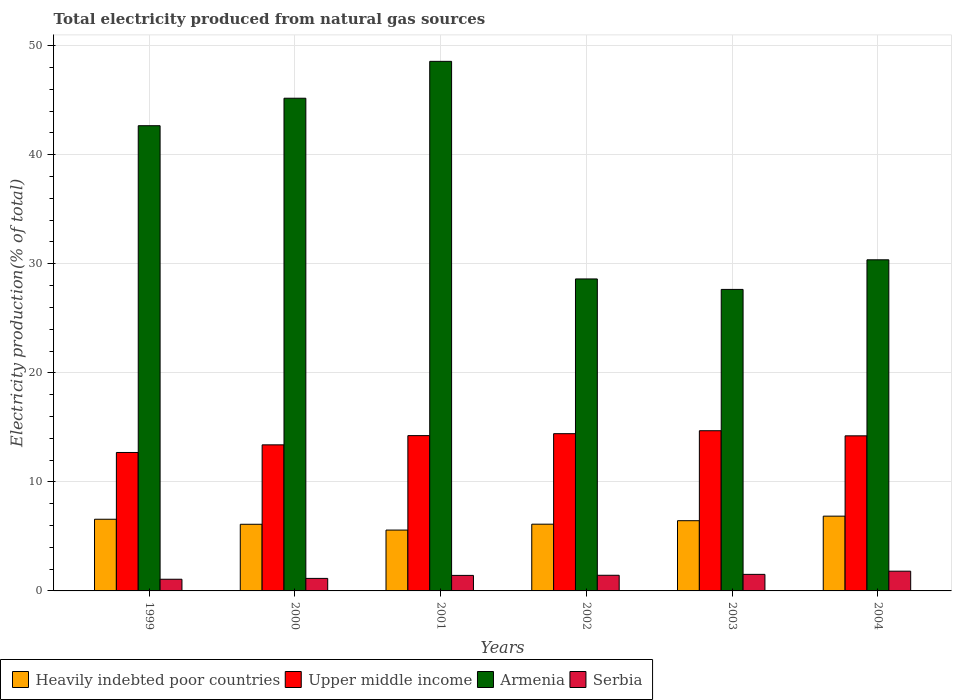How many groups of bars are there?
Offer a very short reply. 6. How many bars are there on the 3rd tick from the right?
Make the answer very short. 4. What is the total electricity produced in Armenia in 2004?
Provide a short and direct response. 30.36. Across all years, what is the maximum total electricity produced in Serbia?
Your answer should be compact. 1.81. Across all years, what is the minimum total electricity produced in Upper middle income?
Make the answer very short. 12.7. What is the total total electricity produced in Armenia in the graph?
Your response must be concise. 223.03. What is the difference between the total electricity produced in Serbia in 1999 and that in 2004?
Your answer should be compact. -0.74. What is the difference between the total electricity produced in Heavily indebted poor countries in 2000 and the total electricity produced in Serbia in 2004?
Give a very brief answer. 4.3. What is the average total electricity produced in Upper middle income per year?
Make the answer very short. 13.94. In the year 2004, what is the difference between the total electricity produced in Upper middle income and total electricity produced in Armenia?
Your response must be concise. -16.14. What is the ratio of the total electricity produced in Serbia in 1999 to that in 2001?
Your answer should be very brief. 0.75. Is the total electricity produced in Serbia in 2000 less than that in 2001?
Ensure brevity in your answer.  Yes. Is the difference between the total electricity produced in Upper middle income in 2000 and 2004 greater than the difference between the total electricity produced in Armenia in 2000 and 2004?
Your answer should be compact. No. What is the difference between the highest and the second highest total electricity produced in Heavily indebted poor countries?
Provide a succinct answer. 0.28. What is the difference between the highest and the lowest total electricity produced in Armenia?
Provide a succinct answer. 20.91. In how many years, is the total electricity produced in Armenia greater than the average total electricity produced in Armenia taken over all years?
Your answer should be compact. 3. Is the sum of the total electricity produced in Upper middle income in 2000 and 2004 greater than the maximum total electricity produced in Heavily indebted poor countries across all years?
Ensure brevity in your answer.  Yes. Is it the case that in every year, the sum of the total electricity produced in Serbia and total electricity produced in Upper middle income is greater than the sum of total electricity produced in Armenia and total electricity produced in Heavily indebted poor countries?
Make the answer very short. No. What does the 3rd bar from the left in 2003 represents?
Your answer should be very brief. Armenia. What does the 1st bar from the right in 2000 represents?
Keep it short and to the point. Serbia. Are all the bars in the graph horizontal?
Your answer should be compact. No. What is the difference between two consecutive major ticks on the Y-axis?
Give a very brief answer. 10. Are the values on the major ticks of Y-axis written in scientific E-notation?
Your answer should be very brief. No. Does the graph contain grids?
Give a very brief answer. Yes. Where does the legend appear in the graph?
Keep it short and to the point. Bottom left. What is the title of the graph?
Offer a terse response. Total electricity produced from natural gas sources. Does "Zimbabwe" appear as one of the legend labels in the graph?
Your response must be concise. No. What is the label or title of the X-axis?
Provide a succinct answer. Years. What is the Electricity production(% of total) of Heavily indebted poor countries in 1999?
Your answer should be very brief. 6.57. What is the Electricity production(% of total) in Upper middle income in 1999?
Offer a terse response. 12.7. What is the Electricity production(% of total) of Armenia in 1999?
Give a very brief answer. 42.66. What is the Electricity production(% of total) of Serbia in 1999?
Give a very brief answer. 1.07. What is the Electricity production(% of total) in Heavily indebted poor countries in 2000?
Keep it short and to the point. 6.11. What is the Electricity production(% of total) in Upper middle income in 2000?
Provide a short and direct response. 13.4. What is the Electricity production(% of total) in Armenia in 2000?
Your answer should be compact. 45.18. What is the Electricity production(% of total) in Serbia in 2000?
Your answer should be very brief. 1.15. What is the Electricity production(% of total) in Heavily indebted poor countries in 2001?
Give a very brief answer. 5.58. What is the Electricity production(% of total) of Upper middle income in 2001?
Ensure brevity in your answer.  14.24. What is the Electricity production(% of total) of Armenia in 2001?
Give a very brief answer. 48.56. What is the Electricity production(% of total) in Serbia in 2001?
Offer a very short reply. 1.42. What is the Electricity production(% of total) of Heavily indebted poor countries in 2002?
Make the answer very short. 6.12. What is the Electricity production(% of total) of Upper middle income in 2002?
Offer a very short reply. 14.42. What is the Electricity production(% of total) in Armenia in 2002?
Provide a short and direct response. 28.61. What is the Electricity production(% of total) in Serbia in 2002?
Provide a short and direct response. 1.43. What is the Electricity production(% of total) in Heavily indebted poor countries in 2003?
Keep it short and to the point. 6.44. What is the Electricity production(% of total) in Upper middle income in 2003?
Keep it short and to the point. 14.69. What is the Electricity production(% of total) of Armenia in 2003?
Your response must be concise. 27.65. What is the Electricity production(% of total) of Serbia in 2003?
Your answer should be compact. 1.52. What is the Electricity production(% of total) of Heavily indebted poor countries in 2004?
Offer a terse response. 6.86. What is the Electricity production(% of total) in Upper middle income in 2004?
Your response must be concise. 14.22. What is the Electricity production(% of total) of Armenia in 2004?
Provide a short and direct response. 30.36. What is the Electricity production(% of total) of Serbia in 2004?
Offer a terse response. 1.81. Across all years, what is the maximum Electricity production(% of total) of Heavily indebted poor countries?
Make the answer very short. 6.86. Across all years, what is the maximum Electricity production(% of total) of Upper middle income?
Offer a terse response. 14.69. Across all years, what is the maximum Electricity production(% of total) of Armenia?
Keep it short and to the point. 48.56. Across all years, what is the maximum Electricity production(% of total) of Serbia?
Keep it short and to the point. 1.81. Across all years, what is the minimum Electricity production(% of total) in Heavily indebted poor countries?
Your response must be concise. 5.58. Across all years, what is the minimum Electricity production(% of total) in Upper middle income?
Give a very brief answer. 12.7. Across all years, what is the minimum Electricity production(% of total) in Armenia?
Offer a very short reply. 27.65. Across all years, what is the minimum Electricity production(% of total) of Serbia?
Offer a terse response. 1.07. What is the total Electricity production(% of total) of Heavily indebted poor countries in the graph?
Make the answer very short. 37.68. What is the total Electricity production(% of total) of Upper middle income in the graph?
Ensure brevity in your answer.  83.67. What is the total Electricity production(% of total) in Armenia in the graph?
Your answer should be very brief. 223.03. What is the total Electricity production(% of total) of Serbia in the graph?
Provide a short and direct response. 8.41. What is the difference between the Electricity production(% of total) of Heavily indebted poor countries in 1999 and that in 2000?
Make the answer very short. 0.46. What is the difference between the Electricity production(% of total) in Upper middle income in 1999 and that in 2000?
Your response must be concise. -0.7. What is the difference between the Electricity production(% of total) in Armenia in 1999 and that in 2000?
Your answer should be compact. -2.52. What is the difference between the Electricity production(% of total) in Serbia in 1999 and that in 2000?
Provide a short and direct response. -0.08. What is the difference between the Electricity production(% of total) of Upper middle income in 1999 and that in 2001?
Your answer should be compact. -1.55. What is the difference between the Electricity production(% of total) of Armenia in 1999 and that in 2001?
Your answer should be very brief. -5.9. What is the difference between the Electricity production(% of total) in Serbia in 1999 and that in 2001?
Your answer should be compact. -0.35. What is the difference between the Electricity production(% of total) in Heavily indebted poor countries in 1999 and that in 2002?
Your answer should be very brief. 0.45. What is the difference between the Electricity production(% of total) in Upper middle income in 1999 and that in 2002?
Your answer should be compact. -1.72. What is the difference between the Electricity production(% of total) of Armenia in 1999 and that in 2002?
Your response must be concise. 14.05. What is the difference between the Electricity production(% of total) of Serbia in 1999 and that in 2002?
Your answer should be compact. -0.36. What is the difference between the Electricity production(% of total) in Heavily indebted poor countries in 1999 and that in 2003?
Keep it short and to the point. 0.13. What is the difference between the Electricity production(% of total) of Upper middle income in 1999 and that in 2003?
Give a very brief answer. -1.99. What is the difference between the Electricity production(% of total) in Armenia in 1999 and that in 2003?
Offer a terse response. 15.01. What is the difference between the Electricity production(% of total) of Serbia in 1999 and that in 2003?
Your answer should be very brief. -0.45. What is the difference between the Electricity production(% of total) of Heavily indebted poor countries in 1999 and that in 2004?
Offer a terse response. -0.28. What is the difference between the Electricity production(% of total) of Upper middle income in 1999 and that in 2004?
Ensure brevity in your answer.  -1.53. What is the difference between the Electricity production(% of total) in Armenia in 1999 and that in 2004?
Provide a succinct answer. 12.3. What is the difference between the Electricity production(% of total) of Serbia in 1999 and that in 2004?
Offer a terse response. -0.74. What is the difference between the Electricity production(% of total) in Heavily indebted poor countries in 2000 and that in 2001?
Make the answer very short. 0.53. What is the difference between the Electricity production(% of total) of Upper middle income in 2000 and that in 2001?
Your answer should be compact. -0.85. What is the difference between the Electricity production(% of total) of Armenia in 2000 and that in 2001?
Ensure brevity in your answer.  -3.38. What is the difference between the Electricity production(% of total) of Serbia in 2000 and that in 2001?
Keep it short and to the point. -0.28. What is the difference between the Electricity production(% of total) of Heavily indebted poor countries in 2000 and that in 2002?
Ensure brevity in your answer.  -0.01. What is the difference between the Electricity production(% of total) in Upper middle income in 2000 and that in 2002?
Your answer should be very brief. -1.02. What is the difference between the Electricity production(% of total) of Armenia in 2000 and that in 2002?
Offer a very short reply. 16.57. What is the difference between the Electricity production(% of total) in Serbia in 2000 and that in 2002?
Your response must be concise. -0.29. What is the difference between the Electricity production(% of total) in Heavily indebted poor countries in 2000 and that in 2003?
Your answer should be very brief. -0.33. What is the difference between the Electricity production(% of total) of Upper middle income in 2000 and that in 2003?
Your response must be concise. -1.3. What is the difference between the Electricity production(% of total) of Armenia in 2000 and that in 2003?
Provide a succinct answer. 17.53. What is the difference between the Electricity production(% of total) in Serbia in 2000 and that in 2003?
Offer a very short reply. -0.37. What is the difference between the Electricity production(% of total) in Heavily indebted poor countries in 2000 and that in 2004?
Your answer should be compact. -0.74. What is the difference between the Electricity production(% of total) of Upper middle income in 2000 and that in 2004?
Ensure brevity in your answer.  -0.83. What is the difference between the Electricity production(% of total) in Armenia in 2000 and that in 2004?
Provide a short and direct response. 14.82. What is the difference between the Electricity production(% of total) of Serbia in 2000 and that in 2004?
Provide a succinct answer. -0.66. What is the difference between the Electricity production(% of total) in Heavily indebted poor countries in 2001 and that in 2002?
Provide a short and direct response. -0.54. What is the difference between the Electricity production(% of total) of Upper middle income in 2001 and that in 2002?
Ensure brevity in your answer.  -0.18. What is the difference between the Electricity production(% of total) in Armenia in 2001 and that in 2002?
Your answer should be compact. 19.95. What is the difference between the Electricity production(% of total) of Serbia in 2001 and that in 2002?
Your answer should be very brief. -0.01. What is the difference between the Electricity production(% of total) of Heavily indebted poor countries in 2001 and that in 2003?
Ensure brevity in your answer.  -0.86. What is the difference between the Electricity production(% of total) of Upper middle income in 2001 and that in 2003?
Offer a terse response. -0.45. What is the difference between the Electricity production(% of total) in Armenia in 2001 and that in 2003?
Offer a terse response. 20.91. What is the difference between the Electricity production(% of total) in Serbia in 2001 and that in 2003?
Offer a terse response. -0.1. What is the difference between the Electricity production(% of total) in Heavily indebted poor countries in 2001 and that in 2004?
Ensure brevity in your answer.  -1.28. What is the difference between the Electricity production(% of total) of Upper middle income in 2001 and that in 2004?
Offer a terse response. 0.02. What is the difference between the Electricity production(% of total) of Armenia in 2001 and that in 2004?
Ensure brevity in your answer.  18.2. What is the difference between the Electricity production(% of total) of Serbia in 2001 and that in 2004?
Your answer should be very brief. -0.39. What is the difference between the Electricity production(% of total) in Heavily indebted poor countries in 2002 and that in 2003?
Your answer should be very brief. -0.32. What is the difference between the Electricity production(% of total) of Upper middle income in 2002 and that in 2003?
Offer a terse response. -0.27. What is the difference between the Electricity production(% of total) in Armenia in 2002 and that in 2003?
Give a very brief answer. 0.96. What is the difference between the Electricity production(% of total) in Serbia in 2002 and that in 2003?
Ensure brevity in your answer.  -0.08. What is the difference between the Electricity production(% of total) of Heavily indebted poor countries in 2002 and that in 2004?
Make the answer very short. -0.74. What is the difference between the Electricity production(% of total) of Upper middle income in 2002 and that in 2004?
Provide a succinct answer. 0.2. What is the difference between the Electricity production(% of total) of Armenia in 2002 and that in 2004?
Give a very brief answer. -1.75. What is the difference between the Electricity production(% of total) of Serbia in 2002 and that in 2004?
Offer a terse response. -0.38. What is the difference between the Electricity production(% of total) in Heavily indebted poor countries in 2003 and that in 2004?
Your response must be concise. -0.42. What is the difference between the Electricity production(% of total) in Upper middle income in 2003 and that in 2004?
Make the answer very short. 0.47. What is the difference between the Electricity production(% of total) of Armenia in 2003 and that in 2004?
Keep it short and to the point. -2.72. What is the difference between the Electricity production(% of total) of Serbia in 2003 and that in 2004?
Give a very brief answer. -0.29. What is the difference between the Electricity production(% of total) in Heavily indebted poor countries in 1999 and the Electricity production(% of total) in Upper middle income in 2000?
Offer a very short reply. -6.82. What is the difference between the Electricity production(% of total) of Heavily indebted poor countries in 1999 and the Electricity production(% of total) of Armenia in 2000?
Provide a short and direct response. -38.61. What is the difference between the Electricity production(% of total) of Heavily indebted poor countries in 1999 and the Electricity production(% of total) of Serbia in 2000?
Provide a short and direct response. 5.42. What is the difference between the Electricity production(% of total) of Upper middle income in 1999 and the Electricity production(% of total) of Armenia in 2000?
Offer a terse response. -32.49. What is the difference between the Electricity production(% of total) in Upper middle income in 1999 and the Electricity production(% of total) in Serbia in 2000?
Provide a succinct answer. 11.55. What is the difference between the Electricity production(% of total) of Armenia in 1999 and the Electricity production(% of total) of Serbia in 2000?
Provide a succinct answer. 41.51. What is the difference between the Electricity production(% of total) in Heavily indebted poor countries in 1999 and the Electricity production(% of total) in Upper middle income in 2001?
Ensure brevity in your answer.  -7.67. What is the difference between the Electricity production(% of total) of Heavily indebted poor countries in 1999 and the Electricity production(% of total) of Armenia in 2001?
Keep it short and to the point. -41.99. What is the difference between the Electricity production(% of total) of Heavily indebted poor countries in 1999 and the Electricity production(% of total) of Serbia in 2001?
Provide a short and direct response. 5.15. What is the difference between the Electricity production(% of total) of Upper middle income in 1999 and the Electricity production(% of total) of Armenia in 2001?
Give a very brief answer. -35.87. What is the difference between the Electricity production(% of total) of Upper middle income in 1999 and the Electricity production(% of total) of Serbia in 2001?
Offer a terse response. 11.27. What is the difference between the Electricity production(% of total) in Armenia in 1999 and the Electricity production(% of total) in Serbia in 2001?
Provide a short and direct response. 41.24. What is the difference between the Electricity production(% of total) in Heavily indebted poor countries in 1999 and the Electricity production(% of total) in Upper middle income in 2002?
Your answer should be very brief. -7.85. What is the difference between the Electricity production(% of total) in Heavily indebted poor countries in 1999 and the Electricity production(% of total) in Armenia in 2002?
Make the answer very short. -22.04. What is the difference between the Electricity production(% of total) of Heavily indebted poor countries in 1999 and the Electricity production(% of total) of Serbia in 2002?
Offer a very short reply. 5.14. What is the difference between the Electricity production(% of total) in Upper middle income in 1999 and the Electricity production(% of total) in Armenia in 2002?
Offer a terse response. -15.91. What is the difference between the Electricity production(% of total) in Upper middle income in 1999 and the Electricity production(% of total) in Serbia in 2002?
Provide a short and direct response. 11.26. What is the difference between the Electricity production(% of total) of Armenia in 1999 and the Electricity production(% of total) of Serbia in 2002?
Your answer should be compact. 41.23. What is the difference between the Electricity production(% of total) in Heavily indebted poor countries in 1999 and the Electricity production(% of total) in Upper middle income in 2003?
Offer a very short reply. -8.12. What is the difference between the Electricity production(% of total) of Heavily indebted poor countries in 1999 and the Electricity production(% of total) of Armenia in 2003?
Offer a terse response. -21.08. What is the difference between the Electricity production(% of total) in Heavily indebted poor countries in 1999 and the Electricity production(% of total) in Serbia in 2003?
Offer a terse response. 5.05. What is the difference between the Electricity production(% of total) in Upper middle income in 1999 and the Electricity production(% of total) in Armenia in 2003?
Make the answer very short. -14.95. What is the difference between the Electricity production(% of total) in Upper middle income in 1999 and the Electricity production(% of total) in Serbia in 2003?
Your answer should be very brief. 11.18. What is the difference between the Electricity production(% of total) in Armenia in 1999 and the Electricity production(% of total) in Serbia in 2003?
Provide a succinct answer. 41.14. What is the difference between the Electricity production(% of total) in Heavily indebted poor countries in 1999 and the Electricity production(% of total) in Upper middle income in 2004?
Offer a terse response. -7.65. What is the difference between the Electricity production(% of total) of Heavily indebted poor countries in 1999 and the Electricity production(% of total) of Armenia in 2004?
Provide a succinct answer. -23.79. What is the difference between the Electricity production(% of total) of Heavily indebted poor countries in 1999 and the Electricity production(% of total) of Serbia in 2004?
Provide a succinct answer. 4.76. What is the difference between the Electricity production(% of total) of Upper middle income in 1999 and the Electricity production(% of total) of Armenia in 2004?
Offer a very short reply. -17.67. What is the difference between the Electricity production(% of total) in Upper middle income in 1999 and the Electricity production(% of total) in Serbia in 2004?
Make the answer very short. 10.89. What is the difference between the Electricity production(% of total) in Armenia in 1999 and the Electricity production(% of total) in Serbia in 2004?
Provide a short and direct response. 40.85. What is the difference between the Electricity production(% of total) of Heavily indebted poor countries in 2000 and the Electricity production(% of total) of Upper middle income in 2001?
Your response must be concise. -8.13. What is the difference between the Electricity production(% of total) in Heavily indebted poor countries in 2000 and the Electricity production(% of total) in Armenia in 2001?
Provide a succinct answer. -42.45. What is the difference between the Electricity production(% of total) of Heavily indebted poor countries in 2000 and the Electricity production(% of total) of Serbia in 2001?
Provide a short and direct response. 4.69. What is the difference between the Electricity production(% of total) of Upper middle income in 2000 and the Electricity production(% of total) of Armenia in 2001?
Your answer should be very brief. -35.17. What is the difference between the Electricity production(% of total) in Upper middle income in 2000 and the Electricity production(% of total) in Serbia in 2001?
Make the answer very short. 11.97. What is the difference between the Electricity production(% of total) in Armenia in 2000 and the Electricity production(% of total) in Serbia in 2001?
Your response must be concise. 43.76. What is the difference between the Electricity production(% of total) in Heavily indebted poor countries in 2000 and the Electricity production(% of total) in Upper middle income in 2002?
Make the answer very short. -8.31. What is the difference between the Electricity production(% of total) of Heavily indebted poor countries in 2000 and the Electricity production(% of total) of Armenia in 2002?
Make the answer very short. -22.5. What is the difference between the Electricity production(% of total) of Heavily indebted poor countries in 2000 and the Electricity production(% of total) of Serbia in 2002?
Ensure brevity in your answer.  4.68. What is the difference between the Electricity production(% of total) in Upper middle income in 2000 and the Electricity production(% of total) in Armenia in 2002?
Offer a very short reply. -15.21. What is the difference between the Electricity production(% of total) in Upper middle income in 2000 and the Electricity production(% of total) in Serbia in 2002?
Keep it short and to the point. 11.96. What is the difference between the Electricity production(% of total) of Armenia in 2000 and the Electricity production(% of total) of Serbia in 2002?
Make the answer very short. 43.75. What is the difference between the Electricity production(% of total) in Heavily indebted poor countries in 2000 and the Electricity production(% of total) in Upper middle income in 2003?
Your answer should be compact. -8.58. What is the difference between the Electricity production(% of total) of Heavily indebted poor countries in 2000 and the Electricity production(% of total) of Armenia in 2003?
Keep it short and to the point. -21.54. What is the difference between the Electricity production(% of total) in Heavily indebted poor countries in 2000 and the Electricity production(% of total) in Serbia in 2003?
Your answer should be compact. 4.59. What is the difference between the Electricity production(% of total) of Upper middle income in 2000 and the Electricity production(% of total) of Armenia in 2003?
Provide a succinct answer. -14.25. What is the difference between the Electricity production(% of total) in Upper middle income in 2000 and the Electricity production(% of total) in Serbia in 2003?
Offer a terse response. 11.88. What is the difference between the Electricity production(% of total) of Armenia in 2000 and the Electricity production(% of total) of Serbia in 2003?
Your answer should be compact. 43.66. What is the difference between the Electricity production(% of total) in Heavily indebted poor countries in 2000 and the Electricity production(% of total) in Upper middle income in 2004?
Give a very brief answer. -8.11. What is the difference between the Electricity production(% of total) of Heavily indebted poor countries in 2000 and the Electricity production(% of total) of Armenia in 2004?
Your answer should be very brief. -24.25. What is the difference between the Electricity production(% of total) in Heavily indebted poor countries in 2000 and the Electricity production(% of total) in Serbia in 2004?
Offer a terse response. 4.3. What is the difference between the Electricity production(% of total) of Upper middle income in 2000 and the Electricity production(% of total) of Armenia in 2004?
Give a very brief answer. -16.97. What is the difference between the Electricity production(% of total) in Upper middle income in 2000 and the Electricity production(% of total) in Serbia in 2004?
Your response must be concise. 11.59. What is the difference between the Electricity production(% of total) in Armenia in 2000 and the Electricity production(% of total) in Serbia in 2004?
Your response must be concise. 43.37. What is the difference between the Electricity production(% of total) of Heavily indebted poor countries in 2001 and the Electricity production(% of total) of Upper middle income in 2002?
Your answer should be compact. -8.84. What is the difference between the Electricity production(% of total) of Heavily indebted poor countries in 2001 and the Electricity production(% of total) of Armenia in 2002?
Provide a short and direct response. -23.03. What is the difference between the Electricity production(% of total) of Heavily indebted poor countries in 2001 and the Electricity production(% of total) of Serbia in 2002?
Your response must be concise. 4.15. What is the difference between the Electricity production(% of total) in Upper middle income in 2001 and the Electricity production(% of total) in Armenia in 2002?
Make the answer very short. -14.37. What is the difference between the Electricity production(% of total) of Upper middle income in 2001 and the Electricity production(% of total) of Serbia in 2002?
Your answer should be compact. 12.81. What is the difference between the Electricity production(% of total) in Armenia in 2001 and the Electricity production(% of total) in Serbia in 2002?
Offer a terse response. 47.13. What is the difference between the Electricity production(% of total) of Heavily indebted poor countries in 2001 and the Electricity production(% of total) of Upper middle income in 2003?
Provide a short and direct response. -9.11. What is the difference between the Electricity production(% of total) in Heavily indebted poor countries in 2001 and the Electricity production(% of total) in Armenia in 2003?
Provide a succinct answer. -22.07. What is the difference between the Electricity production(% of total) of Heavily indebted poor countries in 2001 and the Electricity production(% of total) of Serbia in 2003?
Make the answer very short. 4.06. What is the difference between the Electricity production(% of total) in Upper middle income in 2001 and the Electricity production(% of total) in Armenia in 2003?
Provide a succinct answer. -13.41. What is the difference between the Electricity production(% of total) in Upper middle income in 2001 and the Electricity production(% of total) in Serbia in 2003?
Offer a terse response. 12.72. What is the difference between the Electricity production(% of total) in Armenia in 2001 and the Electricity production(% of total) in Serbia in 2003?
Give a very brief answer. 47.05. What is the difference between the Electricity production(% of total) of Heavily indebted poor countries in 2001 and the Electricity production(% of total) of Upper middle income in 2004?
Provide a succinct answer. -8.64. What is the difference between the Electricity production(% of total) of Heavily indebted poor countries in 2001 and the Electricity production(% of total) of Armenia in 2004?
Give a very brief answer. -24.78. What is the difference between the Electricity production(% of total) of Heavily indebted poor countries in 2001 and the Electricity production(% of total) of Serbia in 2004?
Provide a short and direct response. 3.77. What is the difference between the Electricity production(% of total) in Upper middle income in 2001 and the Electricity production(% of total) in Armenia in 2004?
Your answer should be compact. -16.12. What is the difference between the Electricity production(% of total) in Upper middle income in 2001 and the Electricity production(% of total) in Serbia in 2004?
Your answer should be compact. 12.43. What is the difference between the Electricity production(% of total) of Armenia in 2001 and the Electricity production(% of total) of Serbia in 2004?
Ensure brevity in your answer.  46.75. What is the difference between the Electricity production(% of total) in Heavily indebted poor countries in 2002 and the Electricity production(% of total) in Upper middle income in 2003?
Your answer should be very brief. -8.57. What is the difference between the Electricity production(% of total) of Heavily indebted poor countries in 2002 and the Electricity production(% of total) of Armenia in 2003?
Ensure brevity in your answer.  -21.53. What is the difference between the Electricity production(% of total) in Heavily indebted poor countries in 2002 and the Electricity production(% of total) in Serbia in 2003?
Give a very brief answer. 4.6. What is the difference between the Electricity production(% of total) of Upper middle income in 2002 and the Electricity production(% of total) of Armenia in 2003?
Offer a terse response. -13.23. What is the difference between the Electricity production(% of total) in Upper middle income in 2002 and the Electricity production(% of total) in Serbia in 2003?
Your response must be concise. 12.9. What is the difference between the Electricity production(% of total) of Armenia in 2002 and the Electricity production(% of total) of Serbia in 2003?
Make the answer very short. 27.09. What is the difference between the Electricity production(% of total) of Heavily indebted poor countries in 2002 and the Electricity production(% of total) of Upper middle income in 2004?
Your answer should be very brief. -8.1. What is the difference between the Electricity production(% of total) of Heavily indebted poor countries in 2002 and the Electricity production(% of total) of Armenia in 2004?
Offer a very short reply. -24.24. What is the difference between the Electricity production(% of total) in Heavily indebted poor countries in 2002 and the Electricity production(% of total) in Serbia in 2004?
Your answer should be compact. 4.31. What is the difference between the Electricity production(% of total) of Upper middle income in 2002 and the Electricity production(% of total) of Armenia in 2004?
Provide a short and direct response. -15.94. What is the difference between the Electricity production(% of total) in Upper middle income in 2002 and the Electricity production(% of total) in Serbia in 2004?
Your answer should be very brief. 12.61. What is the difference between the Electricity production(% of total) in Armenia in 2002 and the Electricity production(% of total) in Serbia in 2004?
Your answer should be compact. 26.8. What is the difference between the Electricity production(% of total) in Heavily indebted poor countries in 2003 and the Electricity production(% of total) in Upper middle income in 2004?
Ensure brevity in your answer.  -7.78. What is the difference between the Electricity production(% of total) in Heavily indebted poor countries in 2003 and the Electricity production(% of total) in Armenia in 2004?
Make the answer very short. -23.93. What is the difference between the Electricity production(% of total) in Heavily indebted poor countries in 2003 and the Electricity production(% of total) in Serbia in 2004?
Provide a short and direct response. 4.63. What is the difference between the Electricity production(% of total) in Upper middle income in 2003 and the Electricity production(% of total) in Armenia in 2004?
Your answer should be very brief. -15.67. What is the difference between the Electricity production(% of total) of Upper middle income in 2003 and the Electricity production(% of total) of Serbia in 2004?
Your answer should be compact. 12.88. What is the difference between the Electricity production(% of total) of Armenia in 2003 and the Electricity production(% of total) of Serbia in 2004?
Offer a very short reply. 25.84. What is the average Electricity production(% of total) in Heavily indebted poor countries per year?
Your answer should be compact. 6.28. What is the average Electricity production(% of total) of Upper middle income per year?
Your answer should be very brief. 13.94. What is the average Electricity production(% of total) of Armenia per year?
Your response must be concise. 37.17. What is the average Electricity production(% of total) in Serbia per year?
Your answer should be very brief. 1.4. In the year 1999, what is the difference between the Electricity production(% of total) of Heavily indebted poor countries and Electricity production(% of total) of Upper middle income?
Provide a short and direct response. -6.12. In the year 1999, what is the difference between the Electricity production(% of total) in Heavily indebted poor countries and Electricity production(% of total) in Armenia?
Your answer should be compact. -36.09. In the year 1999, what is the difference between the Electricity production(% of total) in Heavily indebted poor countries and Electricity production(% of total) in Serbia?
Offer a terse response. 5.5. In the year 1999, what is the difference between the Electricity production(% of total) in Upper middle income and Electricity production(% of total) in Armenia?
Offer a terse response. -29.97. In the year 1999, what is the difference between the Electricity production(% of total) of Upper middle income and Electricity production(% of total) of Serbia?
Provide a short and direct response. 11.62. In the year 1999, what is the difference between the Electricity production(% of total) of Armenia and Electricity production(% of total) of Serbia?
Offer a very short reply. 41.59. In the year 2000, what is the difference between the Electricity production(% of total) in Heavily indebted poor countries and Electricity production(% of total) in Upper middle income?
Give a very brief answer. -7.28. In the year 2000, what is the difference between the Electricity production(% of total) in Heavily indebted poor countries and Electricity production(% of total) in Armenia?
Your response must be concise. -39.07. In the year 2000, what is the difference between the Electricity production(% of total) in Heavily indebted poor countries and Electricity production(% of total) in Serbia?
Make the answer very short. 4.96. In the year 2000, what is the difference between the Electricity production(% of total) in Upper middle income and Electricity production(% of total) in Armenia?
Your answer should be very brief. -31.79. In the year 2000, what is the difference between the Electricity production(% of total) of Upper middle income and Electricity production(% of total) of Serbia?
Keep it short and to the point. 12.25. In the year 2000, what is the difference between the Electricity production(% of total) in Armenia and Electricity production(% of total) in Serbia?
Offer a very short reply. 44.03. In the year 2001, what is the difference between the Electricity production(% of total) in Heavily indebted poor countries and Electricity production(% of total) in Upper middle income?
Offer a terse response. -8.66. In the year 2001, what is the difference between the Electricity production(% of total) of Heavily indebted poor countries and Electricity production(% of total) of Armenia?
Offer a terse response. -42.98. In the year 2001, what is the difference between the Electricity production(% of total) in Heavily indebted poor countries and Electricity production(% of total) in Serbia?
Make the answer very short. 4.16. In the year 2001, what is the difference between the Electricity production(% of total) in Upper middle income and Electricity production(% of total) in Armenia?
Your answer should be compact. -34.32. In the year 2001, what is the difference between the Electricity production(% of total) of Upper middle income and Electricity production(% of total) of Serbia?
Make the answer very short. 12.82. In the year 2001, what is the difference between the Electricity production(% of total) of Armenia and Electricity production(% of total) of Serbia?
Give a very brief answer. 47.14. In the year 2002, what is the difference between the Electricity production(% of total) in Heavily indebted poor countries and Electricity production(% of total) in Upper middle income?
Keep it short and to the point. -8.3. In the year 2002, what is the difference between the Electricity production(% of total) in Heavily indebted poor countries and Electricity production(% of total) in Armenia?
Make the answer very short. -22.49. In the year 2002, what is the difference between the Electricity production(% of total) of Heavily indebted poor countries and Electricity production(% of total) of Serbia?
Your answer should be compact. 4.69. In the year 2002, what is the difference between the Electricity production(% of total) of Upper middle income and Electricity production(% of total) of Armenia?
Offer a very short reply. -14.19. In the year 2002, what is the difference between the Electricity production(% of total) of Upper middle income and Electricity production(% of total) of Serbia?
Your answer should be very brief. 12.99. In the year 2002, what is the difference between the Electricity production(% of total) in Armenia and Electricity production(% of total) in Serbia?
Your answer should be compact. 27.18. In the year 2003, what is the difference between the Electricity production(% of total) in Heavily indebted poor countries and Electricity production(% of total) in Upper middle income?
Provide a short and direct response. -8.25. In the year 2003, what is the difference between the Electricity production(% of total) in Heavily indebted poor countries and Electricity production(% of total) in Armenia?
Make the answer very short. -21.21. In the year 2003, what is the difference between the Electricity production(% of total) of Heavily indebted poor countries and Electricity production(% of total) of Serbia?
Provide a short and direct response. 4.92. In the year 2003, what is the difference between the Electricity production(% of total) of Upper middle income and Electricity production(% of total) of Armenia?
Offer a very short reply. -12.96. In the year 2003, what is the difference between the Electricity production(% of total) in Upper middle income and Electricity production(% of total) in Serbia?
Ensure brevity in your answer.  13.17. In the year 2003, what is the difference between the Electricity production(% of total) of Armenia and Electricity production(% of total) of Serbia?
Offer a very short reply. 26.13. In the year 2004, what is the difference between the Electricity production(% of total) of Heavily indebted poor countries and Electricity production(% of total) of Upper middle income?
Your response must be concise. -7.37. In the year 2004, what is the difference between the Electricity production(% of total) in Heavily indebted poor countries and Electricity production(% of total) in Armenia?
Provide a succinct answer. -23.51. In the year 2004, what is the difference between the Electricity production(% of total) of Heavily indebted poor countries and Electricity production(% of total) of Serbia?
Offer a terse response. 5.05. In the year 2004, what is the difference between the Electricity production(% of total) of Upper middle income and Electricity production(% of total) of Armenia?
Provide a succinct answer. -16.14. In the year 2004, what is the difference between the Electricity production(% of total) in Upper middle income and Electricity production(% of total) in Serbia?
Keep it short and to the point. 12.41. In the year 2004, what is the difference between the Electricity production(% of total) of Armenia and Electricity production(% of total) of Serbia?
Provide a short and direct response. 28.56. What is the ratio of the Electricity production(% of total) of Heavily indebted poor countries in 1999 to that in 2000?
Make the answer very short. 1.08. What is the ratio of the Electricity production(% of total) in Upper middle income in 1999 to that in 2000?
Offer a very short reply. 0.95. What is the ratio of the Electricity production(% of total) in Armenia in 1999 to that in 2000?
Provide a succinct answer. 0.94. What is the ratio of the Electricity production(% of total) of Serbia in 1999 to that in 2000?
Provide a short and direct response. 0.93. What is the ratio of the Electricity production(% of total) of Heavily indebted poor countries in 1999 to that in 2001?
Give a very brief answer. 1.18. What is the ratio of the Electricity production(% of total) in Upper middle income in 1999 to that in 2001?
Ensure brevity in your answer.  0.89. What is the ratio of the Electricity production(% of total) of Armenia in 1999 to that in 2001?
Your response must be concise. 0.88. What is the ratio of the Electricity production(% of total) of Serbia in 1999 to that in 2001?
Provide a short and direct response. 0.75. What is the ratio of the Electricity production(% of total) of Heavily indebted poor countries in 1999 to that in 2002?
Your answer should be very brief. 1.07. What is the ratio of the Electricity production(% of total) in Upper middle income in 1999 to that in 2002?
Offer a very short reply. 0.88. What is the ratio of the Electricity production(% of total) of Armenia in 1999 to that in 2002?
Provide a succinct answer. 1.49. What is the ratio of the Electricity production(% of total) of Serbia in 1999 to that in 2002?
Your answer should be very brief. 0.75. What is the ratio of the Electricity production(% of total) of Heavily indebted poor countries in 1999 to that in 2003?
Ensure brevity in your answer.  1.02. What is the ratio of the Electricity production(% of total) in Upper middle income in 1999 to that in 2003?
Keep it short and to the point. 0.86. What is the ratio of the Electricity production(% of total) of Armenia in 1999 to that in 2003?
Ensure brevity in your answer.  1.54. What is the ratio of the Electricity production(% of total) in Serbia in 1999 to that in 2003?
Offer a terse response. 0.71. What is the ratio of the Electricity production(% of total) in Heavily indebted poor countries in 1999 to that in 2004?
Provide a succinct answer. 0.96. What is the ratio of the Electricity production(% of total) in Upper middle income in 1999 to that in 2004?
Make the answer very short. 0.89. What is the ratio of the Electricity production(% of total) of Armenia in 1999 to that in 2004?
Offer a very short reply. 1.41. What is the ratio of the Electricity production(% of total) of Serbia in 1999 to that in 2004?
Your answer should be compact. 0.59. What is the ratio of the Electricity production(% of total) in Heavily indebted poor countries in 2000 to that in 2001?
Ensure brevity in your answer.  1.1. What is the ratio of the Electricity production(% of total) in Upper middle income in 2000 to that in 2001?
Provide a short and direct response. 0.94. What is the ratio of the Electricity production(% of total) in Armenia in 2000 to that in 2001?
Offer a terse response. 0.93. What is the ratio of the Electricity production(% of total) of Serbia in 2000 to that in 2001?
Offer a terse response. 0.81. What is the ratio of the Electricity production(% of total) in Upper middle income in 2000 to that in 2002?
Ensure brevity in your answer.  0.93. What is the ratio of the Electricity production(% of total) of Armenia in 2000 to that in 2002?
Offer a very short reply. 1.58. What is the ratio of the Electricity production(% of total) of Serbia in 2000 to that in 2002?
Your answer should be very brief. 0.8. What is the ratio of the Electricity production(% of total) in Heavily indebted poor countries in 2000 to that in 2003?
Make the answer very short. 0.95. What is the ratio of the Electricity production(% of total) of Upper middle income in 2000 to that in 2003?
Your response must be concise. 0.91. What is the ratio of the Electricity production(% of total) of Armenia in 2000 to that in 2003?
Your response must be concise. 1.63. What is the ratio of the Electricity production(% of total) in Serbia in 2000 to that in 2003?
Keep it short and to the point. 0.76. What is the ratio of the Electricity production(% of total) of Heavily indebted poor countries in 2000 to that in 2004?
Your answer should be very brief. 0.89. What is the ratio of the Electricity production(% of total) of Upper middle income in 2000 to that in 2004?
Provide a short and direct response. 0.94. What is the ratio of the Electricity production(% of total) in Armenia in 2000 to that in 2004?
Make the answer very short. 1.49. What is the ratio of the Electricity production(% of total) of Serbia in 2000 to that in 2004?
Keep it short and to the point. 0.63. What is the ratio of the Electricity production(% of total) of Heavily indebted poor countries in 2001 to that in 2002?
Your answer should be very brief. 0.91. What is the ratio of the Electricity production(% of total) of Upper middle income in 2001 to that in 2002?
Provide a succinct answer. 0.99. What is the ratio of the Electricity production(% of total) of Armenia in 2001 to that in 2002?
Provide a short and direct response. 1.7. What is the ratio of the Electricity production(% of total) in Serbia in 2001 to that in 2002?
Ensure brevity in your answer.  0.99. What is the ratio of the Electricity production(% of total) in Heavily indebted poor countries in 2001 to that in 2003?
Offer a very short reply. 0.87. What is the ratio of the Electricity production(% of total) in Upper middle income in 2001 to that in 2003?
Make the answer very short. 0.97. What is the ratio of the Electricity production(% of total) of Armenia in 2001 to that in 2003?
Your answer should be very brief. 1.76. What is the ratio of the Electricity production(% of total) in Serbia in 2001 to that in 2003?
Your answer should be compact. 0.94. What is the ratio of the Electricity production(% of total) of Heavily indebted poor countries in 2001 to that in 2004?
Make the answer very short. 0.81. What is the ratio of the Electricity production(% of total) in Armenia in 2001 to that in 2004?
Keep it short and to the point. 1.6. What is the ratio of the Electricity production(% of total) in Serbia in 2001 to that in 2004?
Offer a very short reply. 0.79. What is the ratio of the Electricity production(% of total) of Heavily indebted poor countries in 2002 to that in 2003?
Give a very brief answer. 0.95. What is the ratio of the Electricity production(% of total) in Upper middle income in 2002 to that in 2003?
Keep it short and to the point. 0.98. What is the ratio of the Electricity production(% of total) of Armenia in 2002 to that in 2003?
Your answer should be compact. 1.03. What is the ratio of the Electricity production(% of total) of Serbia in 2002 to that in 2003?
Give a very brief answer. 0.94. What is the ratio of the Electricity production(% of total) of Heavily indebted poor countries in 2002 to that in 2004?
Ensure brevity in your answer.  0.89. What is the ratio of the Electricity production(% of total) of Upper middle income in 2002 to that in 2004?
Give a very brief answer. 1.01. What is the ratio of the Electricity production(% of total) of Armenia in 2002 to that in 2004?
Your answer should be compact. 0.94. What is the ratio of the Electricity production(% of total) in Serbia in 2002 to that in 2004?
Give a very brief answer. 0.79. What is the ratio of the Electricity production(% of total) of Heavily indebted poor countries in 2003 to that in 2004?
Ensure brevity in your answer.  0.94. What is the ratio of the Electricity production(% of total) in Upper middle income in 2003 to that in 2004?
Your answer should be compact. 1.03. What is the ratio of the Electricity production(% of total) of Armenia in 2003 to that in 2004?
Give a very brief answer. 0.91. What is the ratio of the Electricity production(% of total) in Serbia in 2003 to that in 2004?
Provide a succinct answer. 0.84. What is the difference between the highest and the second highest Electricity production(% of total) in Heavily indebted poor countries?
Provide a succinct answer. 0.28. What is the difference between the highest and the second highest Electricity production(% of total) in Upper middle income?
Offer a terse response. 0.27. What is the difference between the highest and the second highest Electricity production(% of total) of Armenia?
Give a very brief answer. 3.38. What is the difference between the highest and the second highest Electricity production(% of total) in Serbia?
Ensure brevity in your answer.  0.29. What is the difference between the highest and the lowest Electricity production(% of total) of Heavily indebted poor countries?
Ensure brevity in your answer.  1.28. What is the difference between the highest and the lowest Electricity production(% of total) of Upper middle income?
Your response must be concise. 1.99. What is the difference between the highest and the lowest Electricity production(% of total) in Armenia?
Make the answer very short. 20.91. What is the difference between the highest and the lowest Electricity production(% of total) in Serbia?
Your response must be concise. 0.74. 